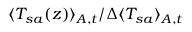Convert formula to latex. <formula><loc_0><loc_0><loc_500><loc_500>\langle T _ { s a } ( z ) \rangle _ { A , t } / \Delta \langle T _ { s a } \rangle _ { A , t }</formula> 